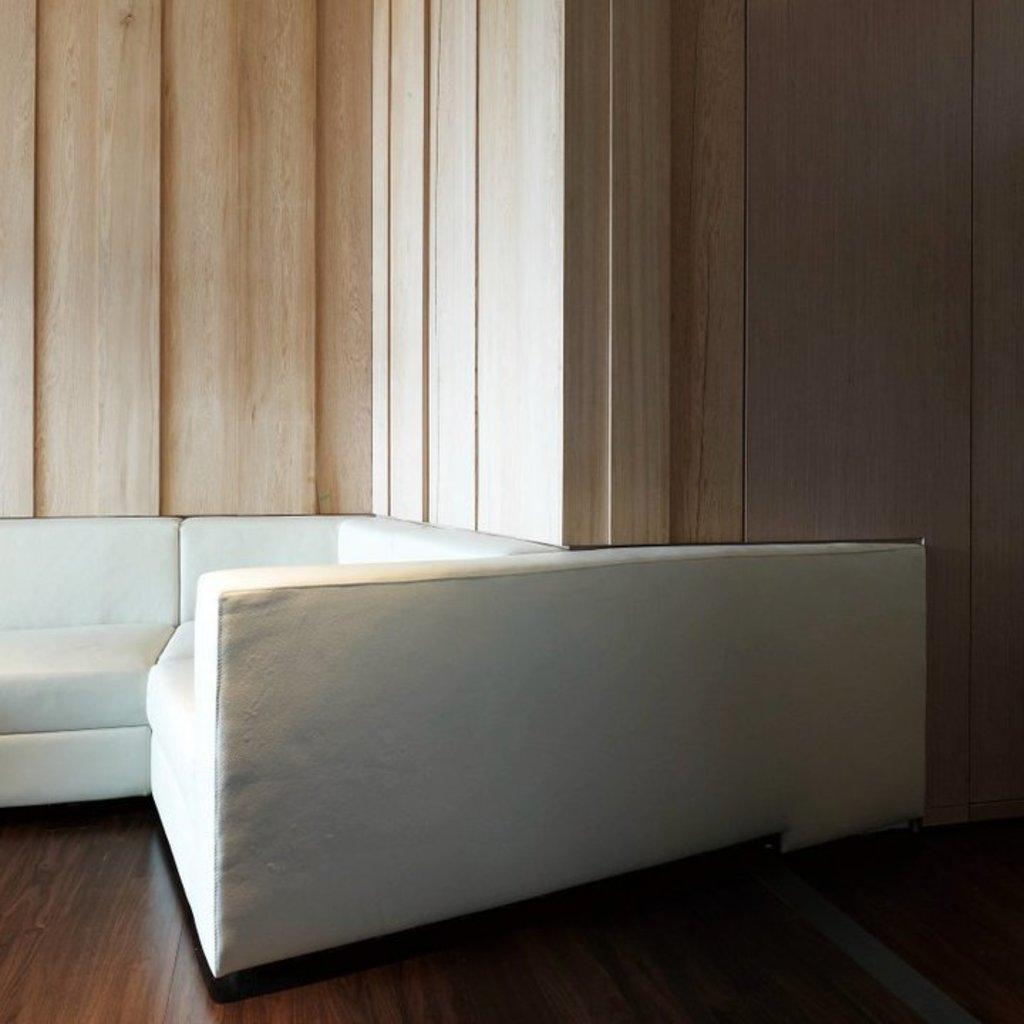What type of furniture is in the image? There is a sofa in the image. Where is the sofa located? The sofa is on the floor. What is behind the sofa in the image? There is a wall behind the sofa. How many potatoes can be seen growing from the root in the image? There are no potatoes or roots present in the image; it features a sofa on the floor with a wall behind it. 